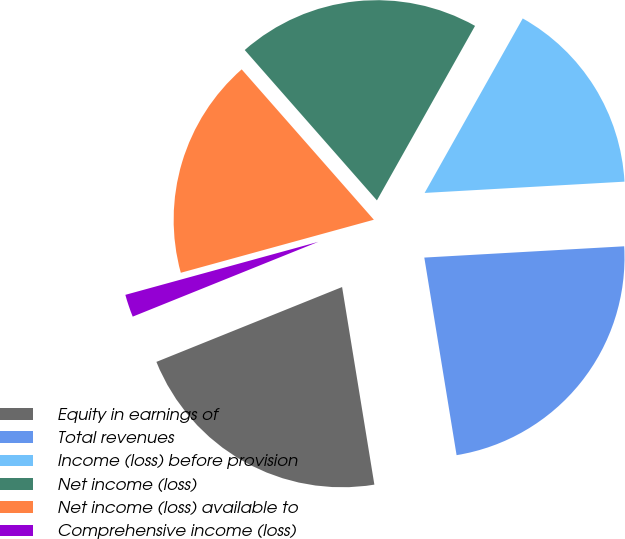<chart> <loc_0><loc_0><loc_500><loc_500><pie_chart><fcel>Equity in earnings of<fcel>Total revenues<fcel>Income (loss) before provision<fcel>Net income (loss)<fcel>Net income (loss) available to<fcel>Comprehensive income (loss)<nl><fcel>21.48%<fcel>23.32%<fcel>15.95%<fcel>19.63%<fcel>17.79%<fcel>1.83%<nl></chart> 